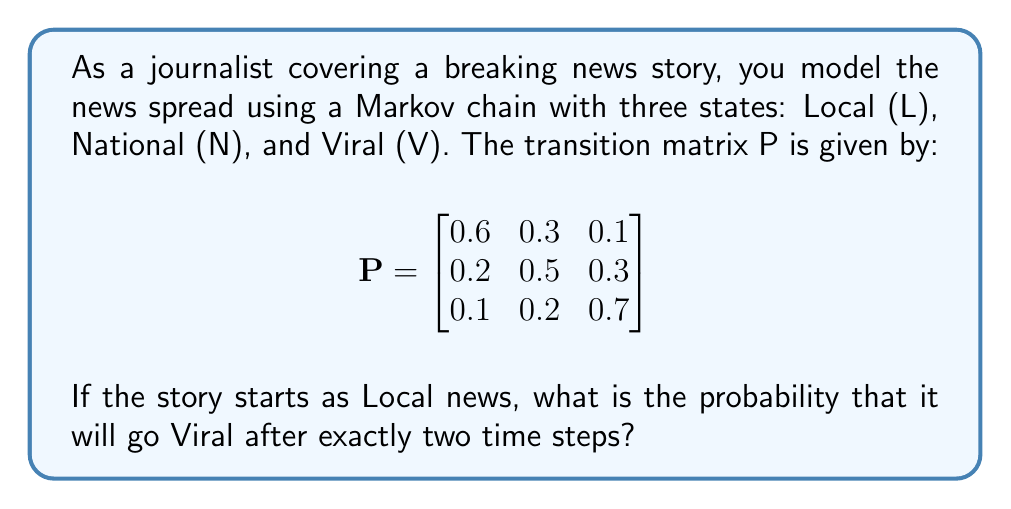What is the answer to this math problem? To solve this problem, we need to use the properties of Markov chains and matrix multiplication. Let's break it down step-by-step:

1) We start in the Local (L) state, which we can represent as a row vector:
   $S_0 = [1 \; 0 \; 0]$

2) To find the probability distribution after two time steps, we need to multiply this initial state by the transition matrix P twice:
   $S_2 = S_0 \cdot P^2$

3) Let's calculate $P^2$:
   $$P^2 = P \cdot P = \begin{bmatrix}
   0.6 & 0.3 & 0.1 \\
   0.2 & 0.5 & 0.3 \\
   0.1 & 0.2 & 0.7
   \end{bmatrix} \cdot \begin{bmatrix}
   0.6 & 0.3 & 0.1 \\
   0.2 & 0.5 & 0.3 \\
   0.1 & 0.2 & 0.7
   \end{bmatrix}$$

4) Performing the matrix multiplication:
   $$P^2 = \begin{bmatrix}
   0.40 & 0.33 & 0.27 \\
   0.29 & 0.38 & 0.33 \\
   0.22 & 0.31 & 0.47
   \end{bmatrix}$$

5) Now, we multiply our initial state by $P^2$:
   $S_2 = [1 \; 0 \; 0] \cdot \begin{bmatrix}
   0.40 & 0.33 & 0.27 \\
   0.29 & 0.38 & 0.33 \\
   0.22 & 0.31 & 0.47
   \end{bmatrix}$

6) This results in:
   $S_2 = [0.40 \; 0.33 \; 0.27]$

7) The probability of being in the Viral state after two time steps is the third element of this vector: 0.27 or 27%.
Answer: 0.27 